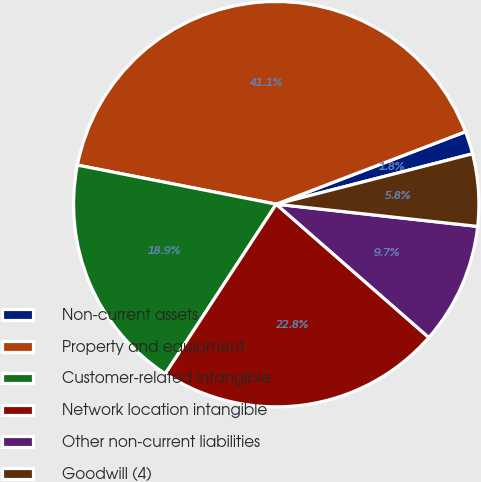<chart> <loc_0><loc_0><loc_500><loc_500><pie_chart><fcel>Non-current assets<fcel>Property and equipment<fcel>Customer-related intangible<fcel>Network location intangible<fcel>Other non-current liabilities<fcel>Goodwill (4)<nl><fcel>1.82%<fcel>41.09%<fcel>18.87%<fcel>22.79%<fcel>9.68%<fcel>5.75%<nl></chart> 